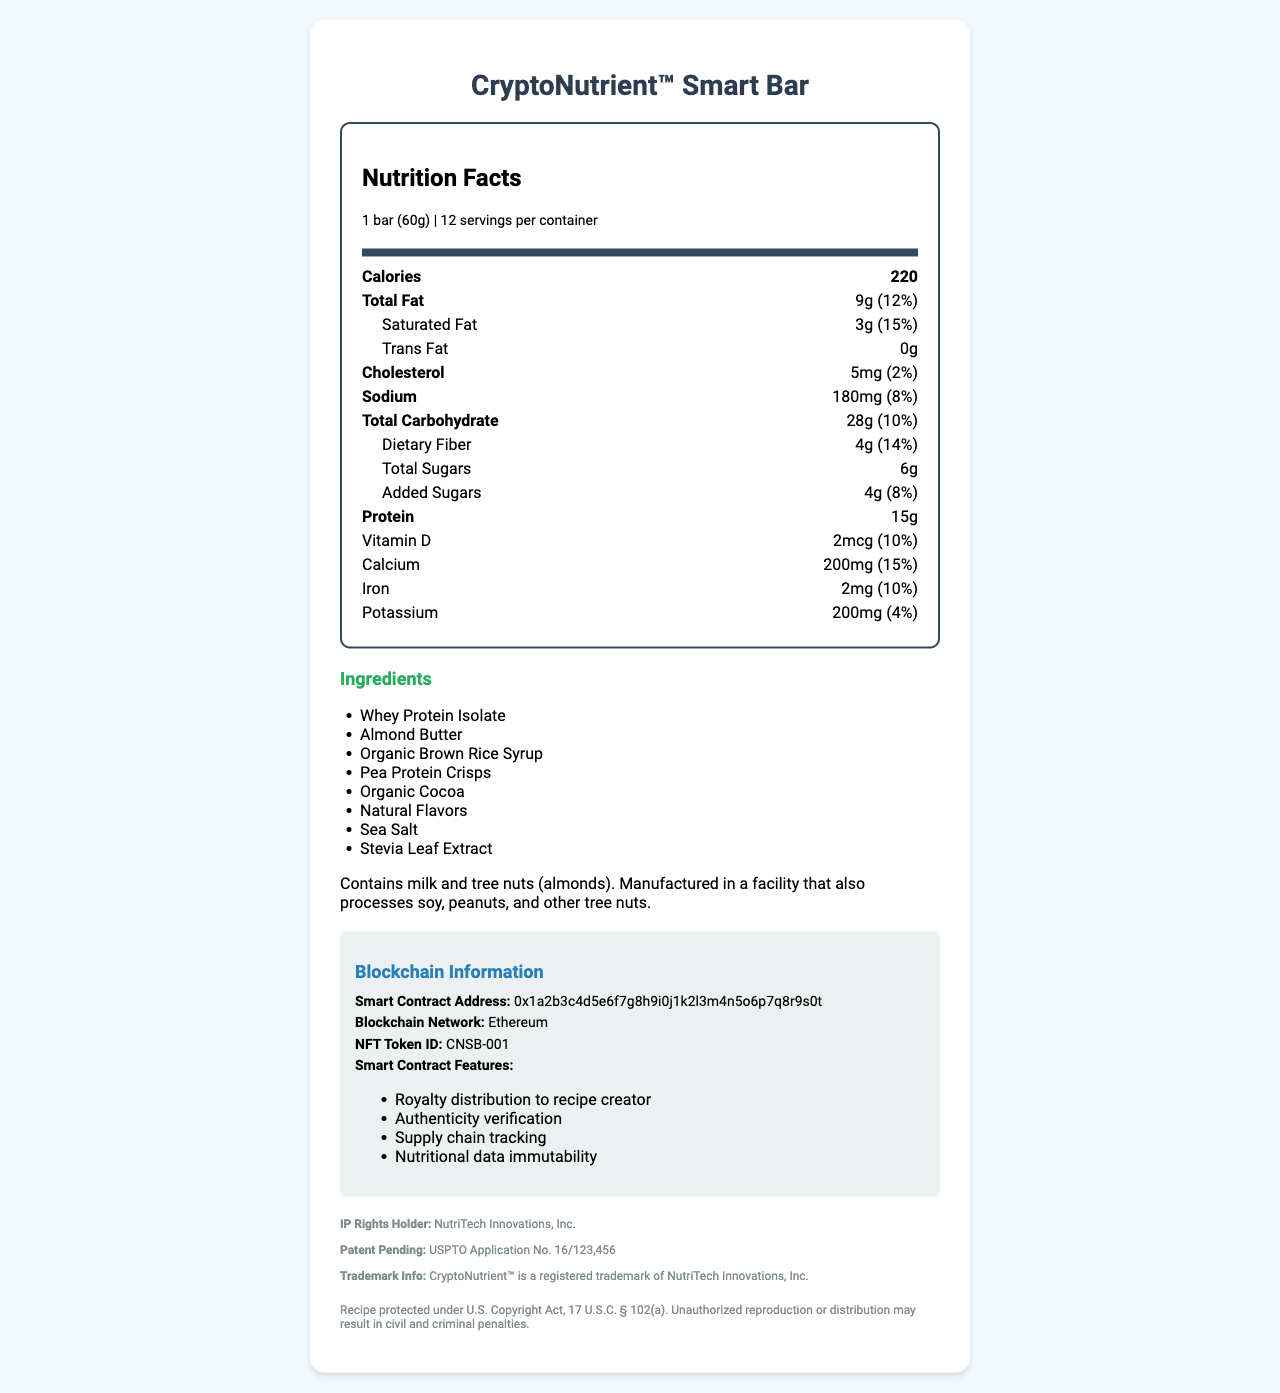what is the serving size of the CryptoNutrient™ Smart Bar? The serving size is explicitly mentioned under the "serving info" section in the document.
Answer: 1 bar (60g) how many calories are in one serving of the CryptoNutrient™ Smart Bar? The number of calories per serving is listed in a bold nutrient row under the "Nutrition Facts" section.
Answer: 220 how much total fat does one bar contain? The total fat amount and its daily value percentage are listed within the "Total Fat" row in the "Nutrition Facts" section.
Answer: 9g (12%) what are the main ingredients in the CryptoNutrient™ Smart Bar? The ingredients are listed in the "Ingredients" section.
Answer: Whey Protein Isolate, Almond Butter, Organic Brown Rice Syrup, Pea Protein Crisps, Organic Cocoa, Natural Flavors, Sea Salt, Stevia Leaf Extract how much protein does each bar provide? The protein content is listed under the "Nutrition Facts" section in a bold nutrient row.
Answer: 15g which organization holds the intellectual property rights for this product? The IP rights holder is mentioned under the "IP Info" section in the document.
Answer: NutriTech Innovations, Inc. what is the smart contract address associated with this product? The smart contract address is provided under the "Blockchain Information" section.
Answer: 0x1a2b3c4d5e6f7g8h9i0j1k2l3m4n5o6p7q8r9s0t which blockchain network is used for this product? The blockchain network details can be found in the "Blockchain Information" section.
Answer: Ethereum what legal protections are cited for the CryptoNutrient™ Smart Bar recipe? The legal protections are mentioned in the "Legal Disclaimer" at the bottom of the document.
Answer: Recipe protected under U.S. Copyright Act, 17 U.S.C. § 102(a). Unauthorized reproduction or distribution may result in civil and criminal penalties. what is the distributed feature listed under the smart contract features? A. Supply chain tracking B. Nutritional data immutability C. Royalty distribution to recipe creator The correct option is "Royalty distribution to recipe creator," which is listed among the smart contract features.
Answer: C which item is NOT part of the smart contract features? 1. Royalty distribution 2. Authenticity verification 3. Calorie reduction 4. Supply chain tracking "Calorie reduction" is not listed among the smart contract features. The features listed are "Royalty distribution," "Authenticity verification," and "Supply chain tracking."
Answer: 3 does the product contain any tree nuts? The allergen information under the "Ingredients" section mentions that the product contains tree nuts (almonds).
Answer: Yes summarize the information given in the document. The document combines nutritional, ingredient, legal, and blockchain information about the CryptoNutrient™ Smart Bar, offering a comprehensive overview of the product.
Answer: The document details the nutrition facts, ingredients, allergens, intellectual property, smart contract information, and legal disclaimers for the CryptoNutrient™ Smart Bar. It includes serving size, calorie content, and breakdowns of fats, proteins, carbohydrates, and various vitamins and minerals. The ingredients list mentions potential allergens. Blockchain and smart contract features are described, along with intellectual property and trademark details. who are the primary customers for this product? The document does not specify the target customers or demographics for the CryptoNutrient™ Smart Bar.
Answer: Cannot be determined 